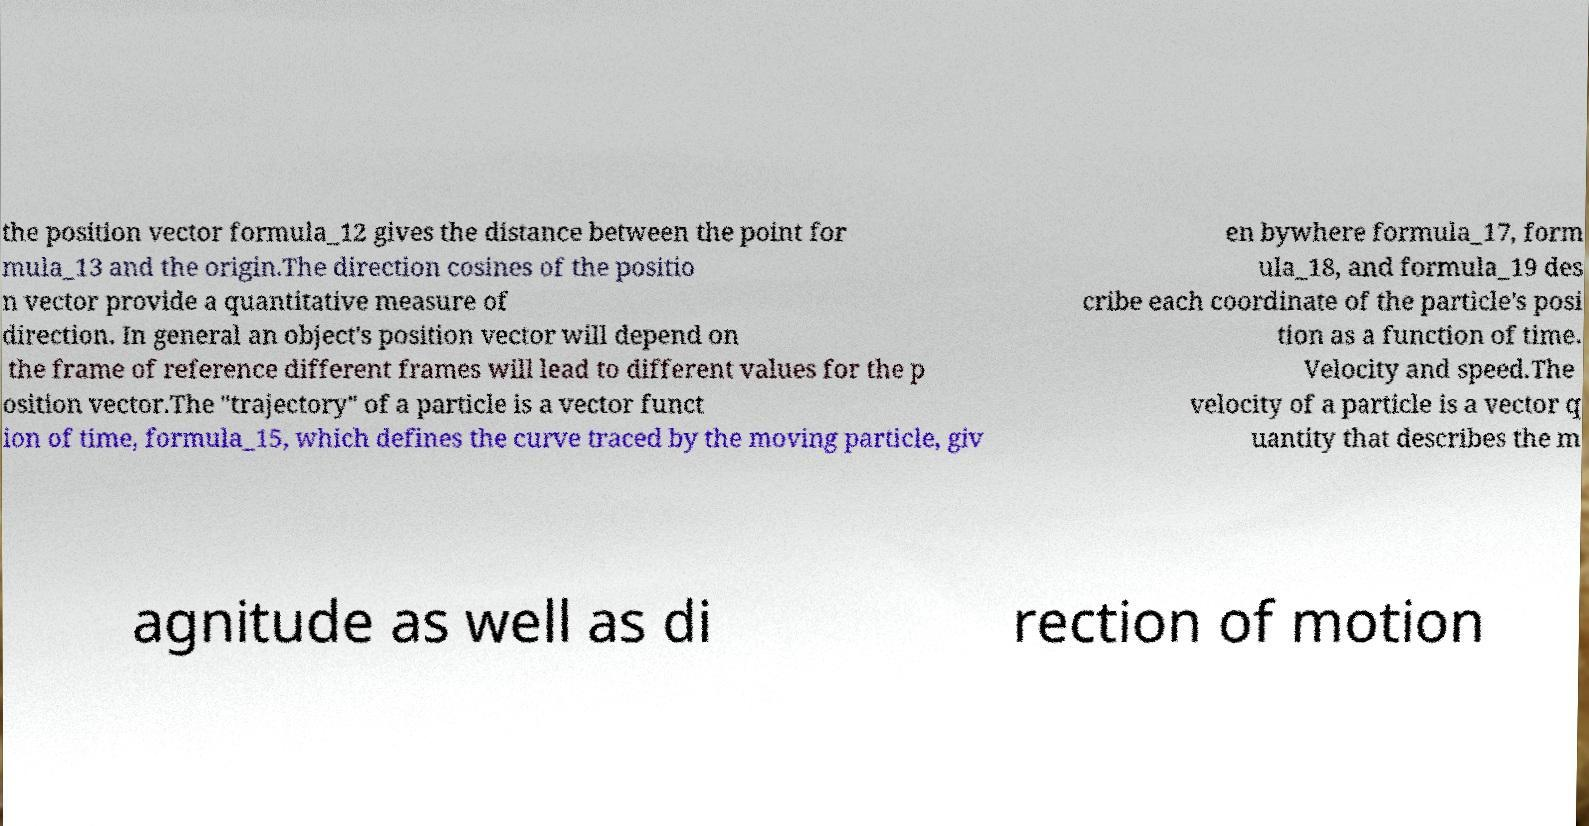Please identify and transcribe the text found in this image. the position vector formula_12 gives the distance between the point for mula_13 and the origin.The direction cosines of the positio n vector provide a quantitative measure of direction. In general an object's position vector will depend on the frame of reference different frames will lead to different values for the p osition vector.The "trajectory" of a particle is a vector funct ion of time, formula_15, which defines the curve traced by the moving particle, giv en bywhere formula_17, form ula_18, and formula_19 des cribe each coordinate of the particle's posi tion as a function of time. Velocity and speed.The velocity of a particle is a vector q uantity that describes the m agnitude as well as di rection of motion 